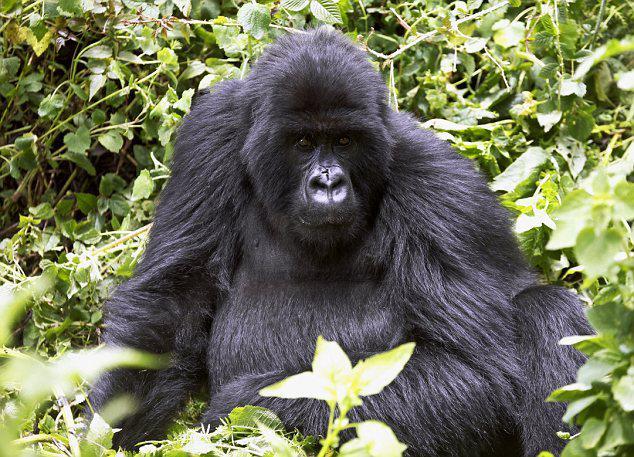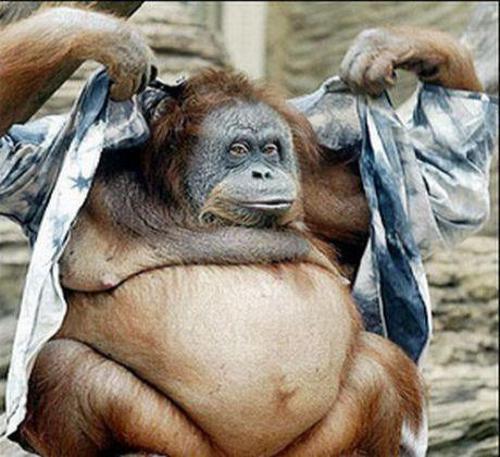The first image is the image on the left, the second image is the image on the right. Examine the images to the left and right. Is the description "A gorilla is shown with an item of clothing in each image." accurate? Answer yes or no. No. The first image is the image on the left, the second image is the image on the right. For the images shown, is this caption "the left and right image contains the same number of gorillas with human clothing." true? Answer yes or no. No. 